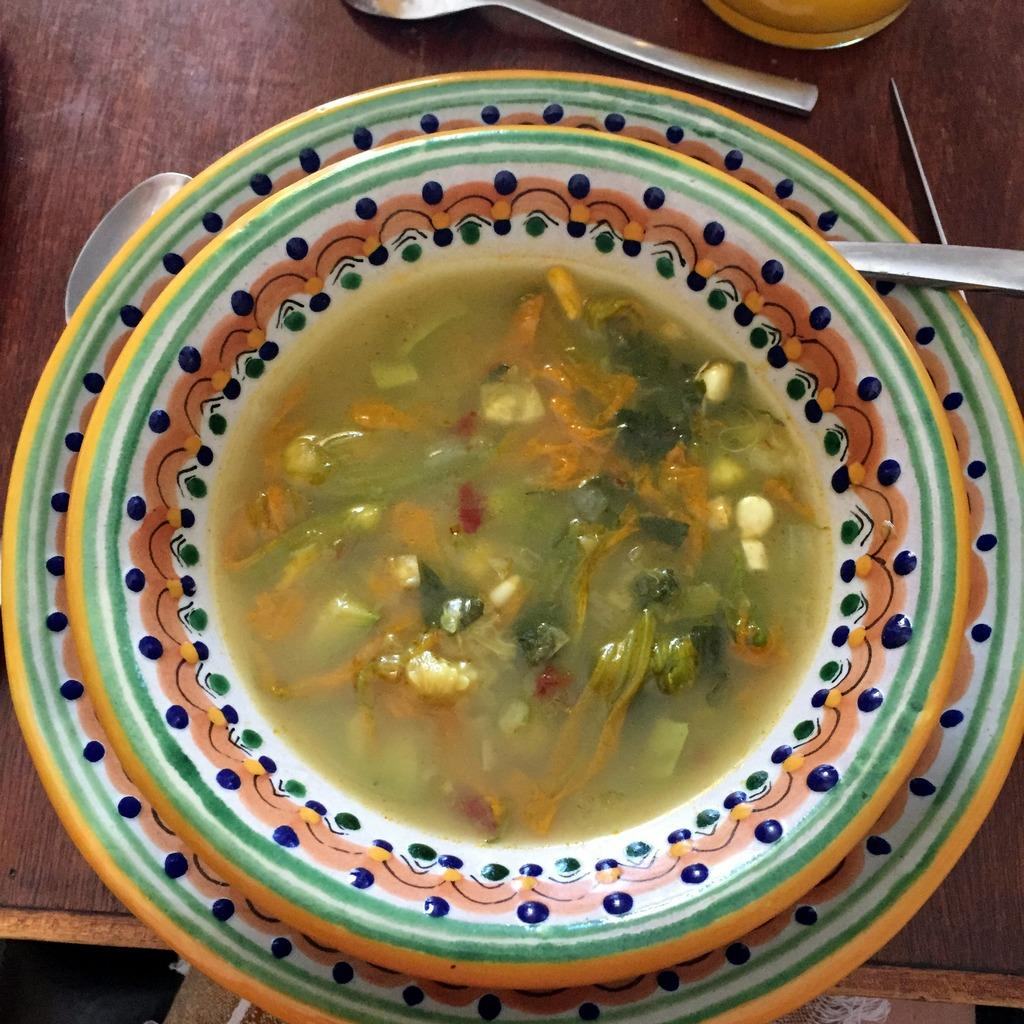What is in the bowl that is visible in the image? There is food in a bowl in the image. Where are the spoons located in the image? The spoons are on a table in the background of the image. What story is being told by the food in the image? The food in the bowl does not tell a story; it is simply food in a bowl. Can you see anyone running in the image? There is no indication of anyone running in the image. 